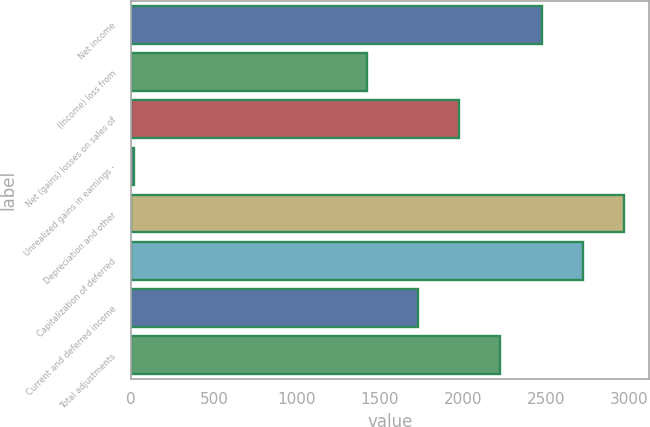Convert chart. <chart><loc_0><loc_0><loc_500><loc_500><bar_chart><fcel>Net income<fcel>(Income) loss from<fcel>Net (gains) losses on sales of<fcel>Unrealized gains in earnings -<fcel>Depreciation and other<fcel>Capitalization of deferred<fcel>Current and deferred income<fcel>Total adjustments<nl><fcel>2475.3<fcel>1419<fcel>1977.1<fcel>20<fcel>2973.5<fcel>2724.4<fcel>1728<fcel>2226.2<nl></chart> 